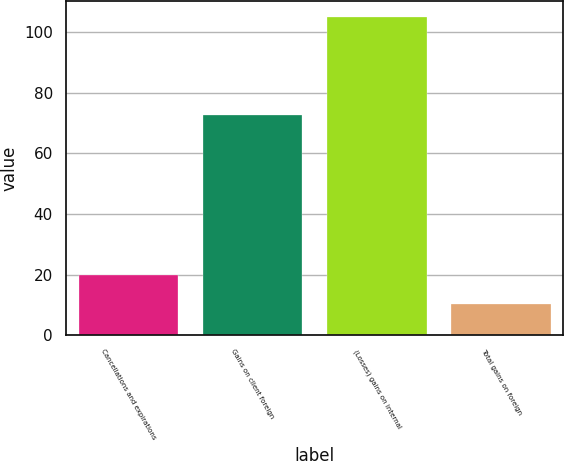Convert chart to OTSL. <chart><loc_0><loc_0><loc_500><loc_500><bar_chart><fcel>Cancellations and expirations<fcel>Gains on client foreign<fcel>(Losses) gains on internal<fcel>Total gains on foreign<nl><fcel>19.79<fcel>72.7<fcel>105.2<fcel>10.3<nl></chart> 